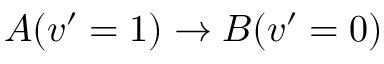Convert formula to latex. <formula><loc_0><loc_0><loc_500><loc_500>A ( v ^ { \prime } = 1 ) \rightarrow B ( v ^ { \prime } = 0 )</formula> 